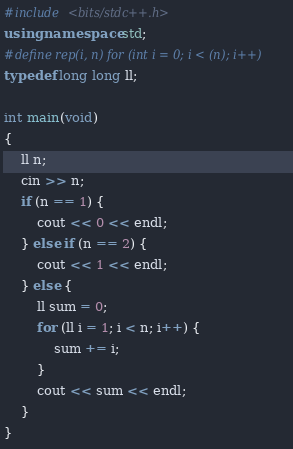Convert code to text. <code><loc_0><loc_0><loc_500><loc_500><_C++_>#include <bits/stdc++.h>
using namespace std;
#define rep(i, n) for (int i = 0; i < (n); i++)
typedef long long ll;

int main(void)
{
    ll n;
    cin >> n;
    if (n == 1) {
        cout << 0 << endl;
    } else if (n == 2) {
        cout << 1 << endl;
    } else {
        ll sum = 0;
        for (ll i = 1; i < n; i++) {
            sum += i;
        }
        cout << sum << endl;
    }
}


</code> 